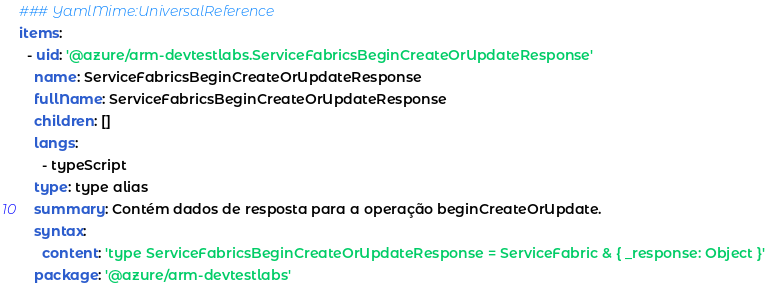<code> <loc_0><loc_0><loc_500><loc_500><_YAML_>### YamlMime:UniversalReference
items:
  - uid: '@azure/arm-devtestlabs.ServiceFabricsBeginCreateOrUpdateResponse'
    name: ServiceFabricsBeginCreateOrUpdateResponse
    fullName: ServiceFabricsBeginCreateOrUpdateResponse
    children: []
    langs:
      - typeScript
    type: type alias
    summary: Contém dados de resposta para a operação beginCreateOrUpdate.
    syntax:
      content: 'type ServiceFabricsBeginCreateOrUpdateResponse = ServiceFabric & { _response: Object }'
    package: '@azure/arm-devtestlabs'</code> 